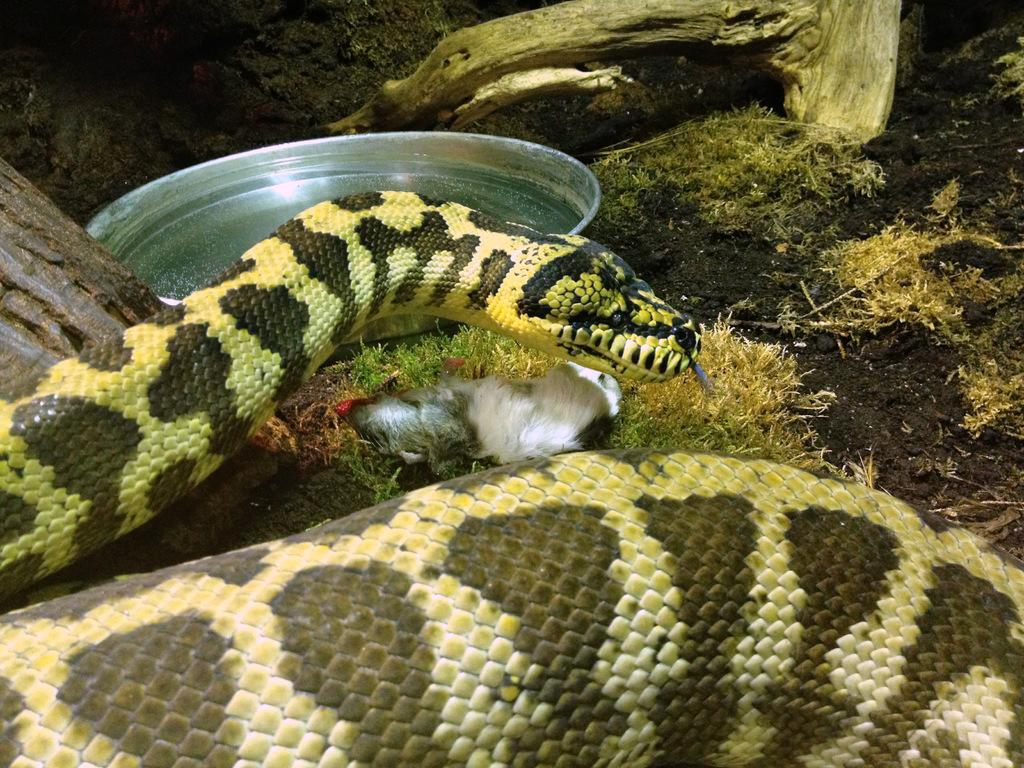What animal is present in the image? There is a snake in the image. What colors can be seen on the snake? The snake has black and yellow coloring. What object is on the ground in front of the snake? There is a plate on the ground in front of the snake. What type of vein is visible in the image? There is no vein present in the image; it features a snake and a plate on the ground. What type of drink is being served on the plate in the image? There is no drink present in the image; only a snake and a plate on the ground are visible. 